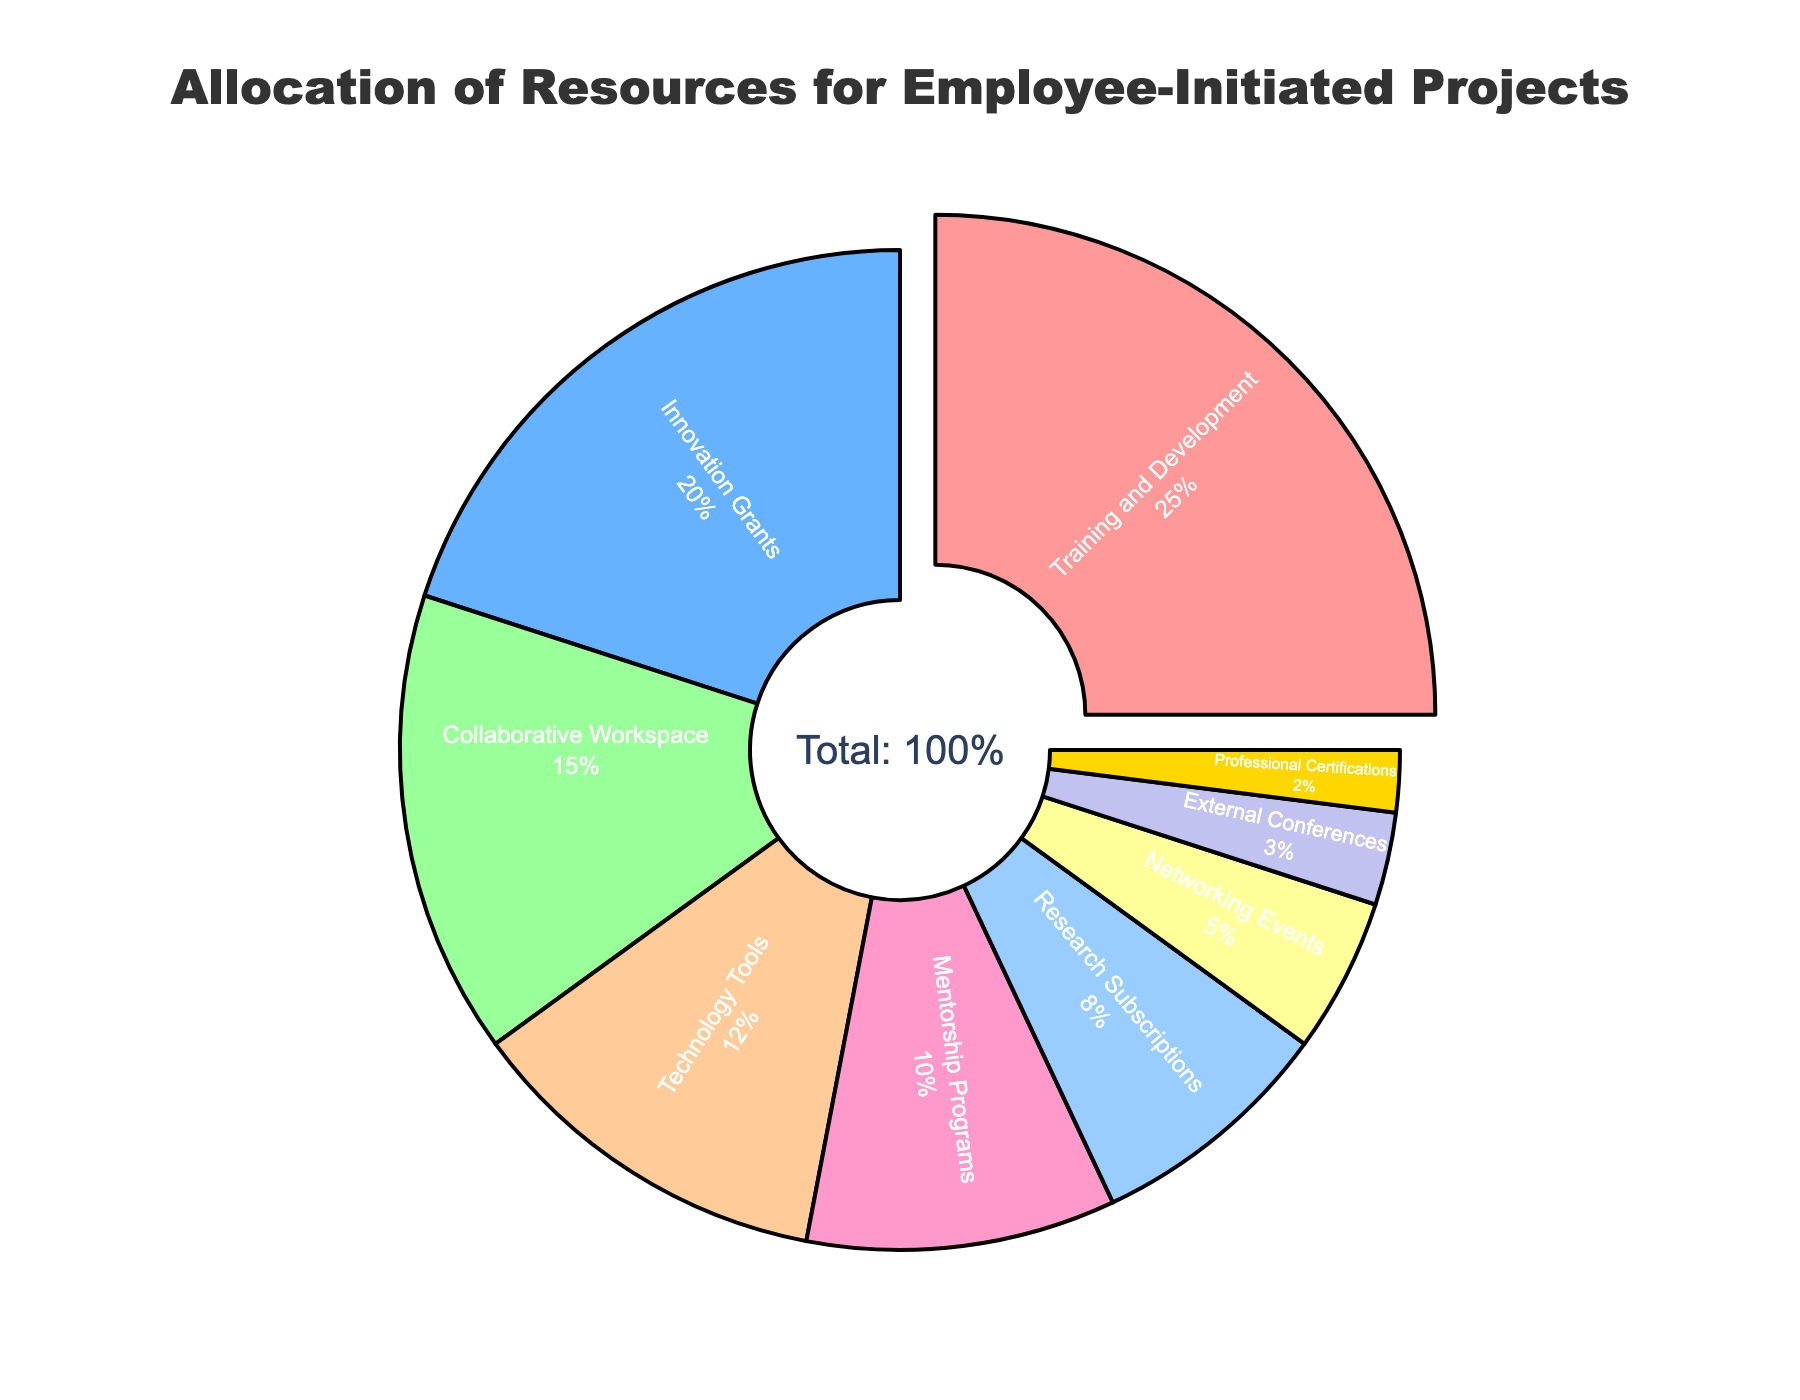How is the training and development allocation highlighted in the pie chart? The training and development allocation is pulled out from the pie chart, making it visually distinct from other segments. This is achieved by slightly detaching the segment from the center.
Answer: Pulled out Which two resources have the closest allocation percentages, and what are they? The allocations that are closest to each other are Mentorship Programs (10%) and Research Subscriptions (8%). This can be observed as their slice sizes are very similar.
Answer: Mentorship Programs and Research Subscriptions Which resource allocation is approximately double the allocation for Professional Certifications? The Networking Events allocation is approximately double the allocation for Professional Certifications. Networking Events is 5%, roughly 2.5 times the 2% for Professional Certifications.
Answer: Networking Events What is the combined allocation percentage for Training and Development, and Innovation Grants? The Training and Development allocation is 25% and Innovation Grants allocation is 20%. Adding these gives 25% + 20% = 45%.
Answer: 45% How do the allocations of Collaborative Workspace and Technology Tools compare visually? The allocation for Collaborative Workspace (15%) is larger than for Technology Tools (12%), as the slice for Collaborative Workspace is visibly larger.
Answer: Collaborative Workspace is larger Which allocation is represented by the smallest slice, and what is its percentage? The smallest slice represents Professional Certifications with a 2% allocation. This can be observed as Professional Certifications has the smallest segment in the pie chart.
Answer: Professional Certifications, 2% Which resource type is allocated exactly one-third of the total allocated for Training and Development? Research Subscriptions (8%) is approximately one-third of the allocation for Training and Development (25%), since 25 / 3 ≈ 8.33.
Answer: Research Subscriptions If these allocations are visualized using different colors, which allocation is associated with the golden color? External Conferences is associated with the golden color. This can be identified by looking at the corresponding colored slice in the pie chart.
Answer: External Conferences By how much does the allocation for Technology Tools exceed that for Networking Events? The allocation for Technology Tools is 12% while for Networking Events it is 5%. The difference is 12% - 5% = 7%.
Answer: 7% 